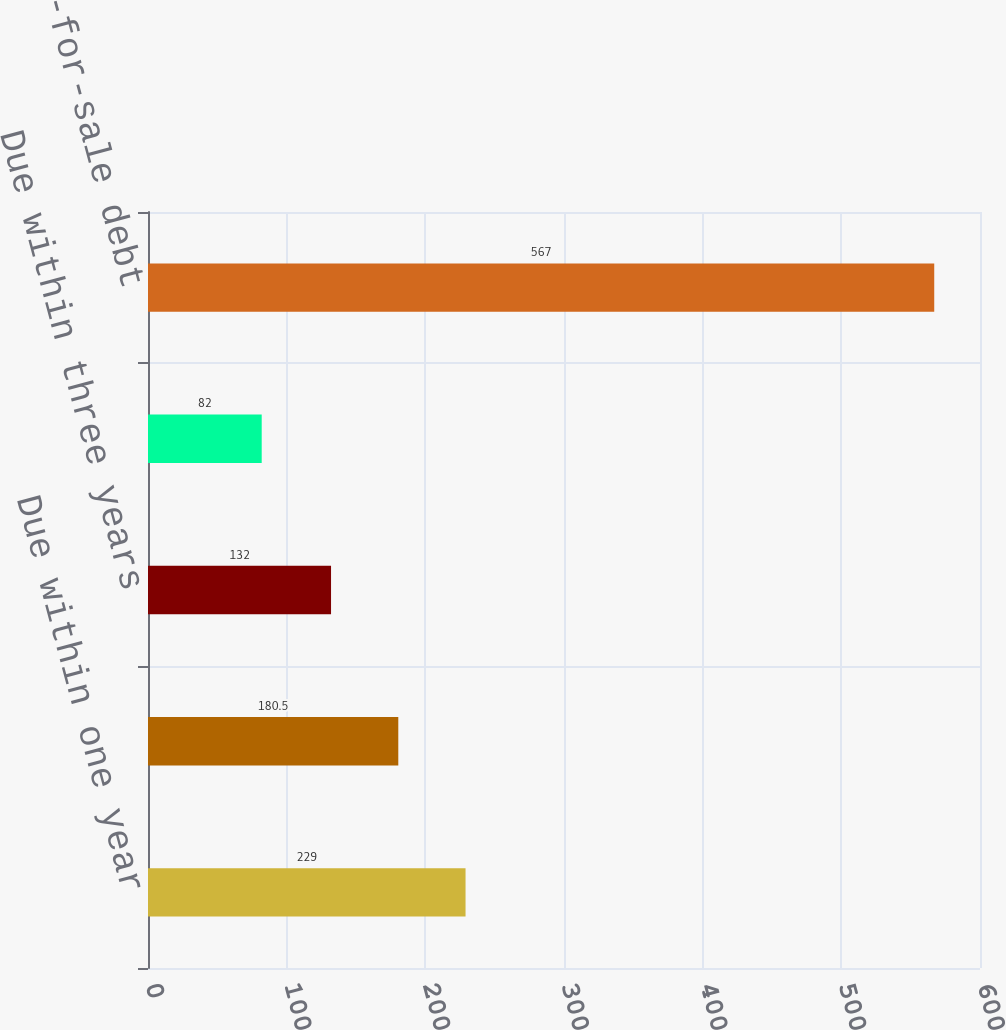Convert chart to OTSL. <chart><loc_0><loc_0><loc_500><loc_500><bar_chart><fcel>Due within one year<fcel>Due within two years<fcel>Due within three years<fcel>Due after three years<fcel>Total available-for-sale debt<nl><fcel>229<fcel>180.5<fcel>132<fcel>82<fcel>567<nl></chart> 